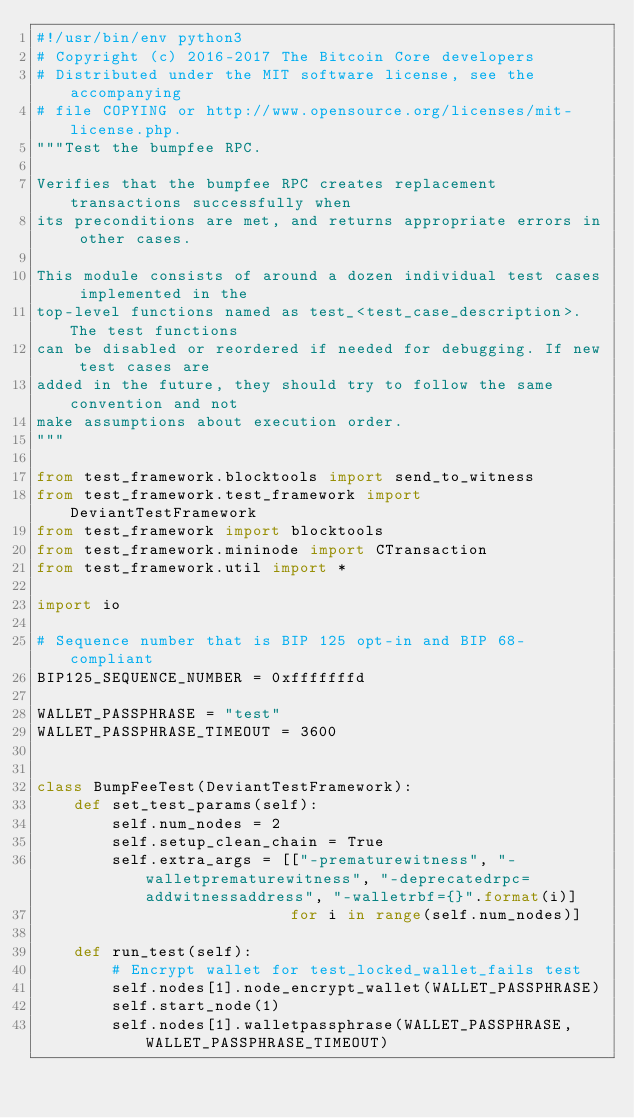Convert code to text. <code><loc_0><loc_0><loc_500><loc_500><_Python_>#!/usr/bin/env python3
# Copyright (c) 2016-2017 The Bitcoin Core developers
# Distributed under the MIT software license, see the accompanying
# file COPYING or http://www.opensource.org/licenses/mit-license.php.
"""Test the bumpfee RPC.

Verifies that the bumpfee RPC creates replacement transactions successfully when
its preconditions are met, and returns appropriate errors in other cases.

This module consists of around a dozen individual test cases implemented in the
top-level functions named as test_<test_case_description>. The test functions
can be disabled or reordered if needed for debugging. If new test cases are
added in the future, they should try to follow the same convention and not
make assumptions about execution order.
"""

from test_framework.blocktools import send_to_witness
from test_framework.test_framework import DeviantTestFramework
from test_framework import blocktools
from test_framework.mininode import CTransaction
from test_framework.util import *

import io

# Sequence number that is BIP 125 opt-in and BIP 68-compliant
BIP125_SEQUENCE_NUMBER = 0xfffffffd

WALLET_PASSPHRASE = "test"
WALLET_PASSPHRASE_TIMEOUT = 3600


class BumpFeeTest(DeviantTestFramework):
    def set_test_params(self):
        self.num_nodes = 2
        self.setup_clean_chain = True
        self.extra_args = [["-prematurewitness", "-walletprematurewitness", "-deprecatedrpc=addwitnessaddress", "-walletrbf={}".format(i)]
                           for i in range(self.num_nodes)]

    def run_test(self):
        # Encrypt wallet for test_locked_wallet_fails test
        self.nodes[1].node_encrypt_wallet(WALLET_PASSPHRASE)
        self.start_node(1)
        self.nodes[1].walletpassphrase(WALLET_PASSPHRASE, WALLET_PASSPHRASE_TIMEOUT)
</code> 